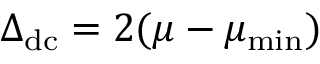<formula> <loc_0><loc_0><loc_500><loc_500>\begin{array} { r } { \Delta _ { d c } = 2 ( \mu - \mu _ { \min } ) } \end{array}</formula> 